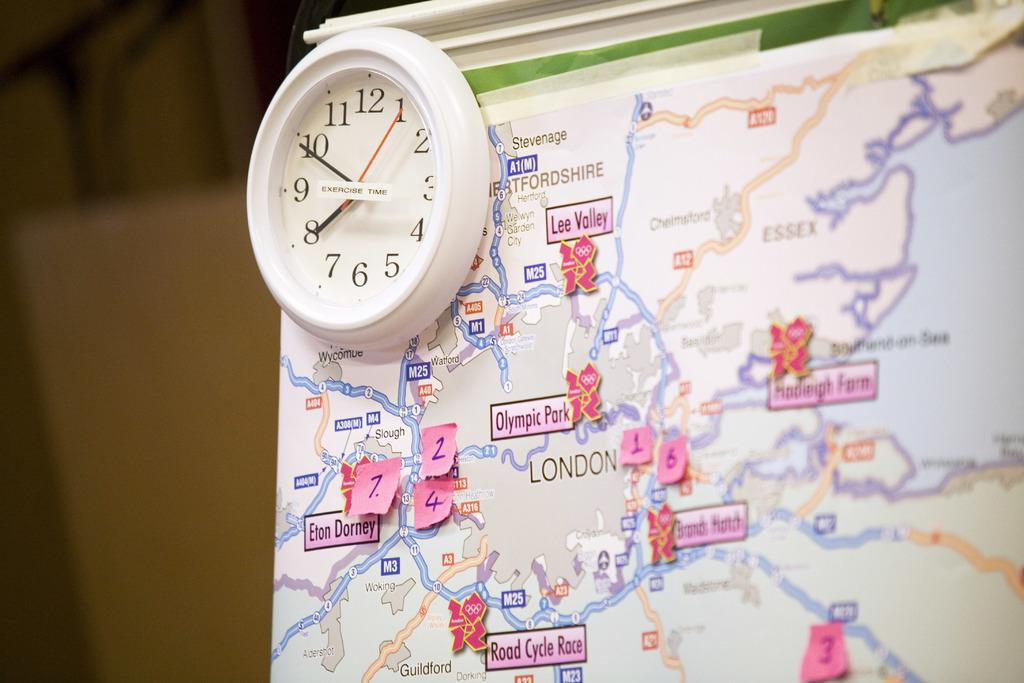Provide a one-sentence caption for the provided image. A map of London has small post it notes with numbers on them attached to it. 